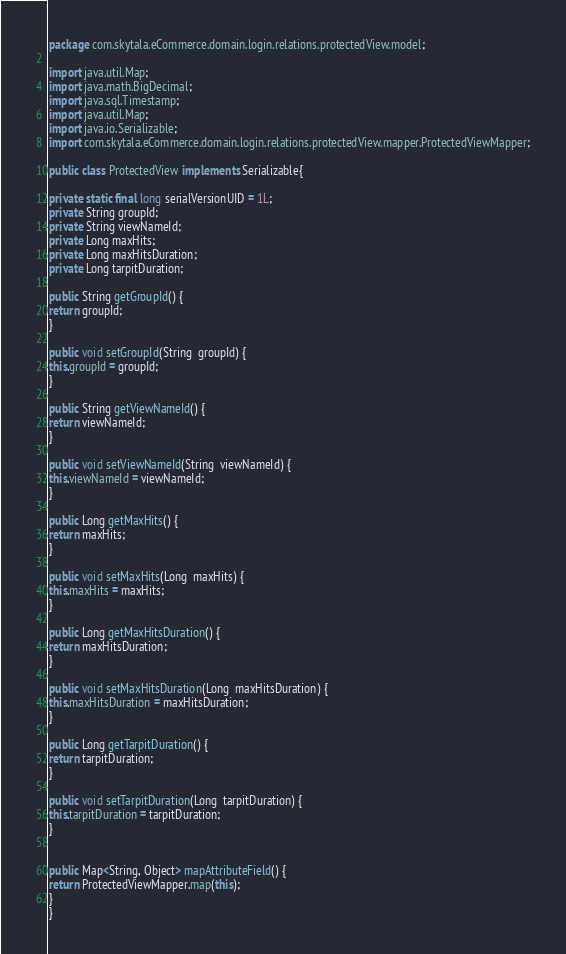Convert code to text. <code><loc_0><loc_0><loc_500><loc_500><_Java_>package com.skytala.eCommerce.domain.login.relations.protectedView.model;

import java.util.Map;
import java.math.BigDecimal;
import java.sql.Timestamp;
import java.util.Map;
import java.io.Serializable;
import com.skytala.eCommerce.domain.login.relations.protectedView.mapper.ProtectedViewMapper;

public class ProtectedView implements Serializable{

private static final long serialVersionUID = 1L;
private String groupId;
private String viewNameId;
private Long maxHits;
private Long maxHitsDuration;
private Long tarpitDuration;

public String getGroupId() {
return groupId;
}

public void setGroupId(String  groupId) {
this.groupId = groupId;
}

public String getViewNameId() {
return viewNameId;
}

public void setViewNameId(String  viewNameId) {
this.viewNameId = viewNameId;
}

public Long getMaxHits() {
return maxHits;
}

public void setMaxHits(Long  maxHits) {
this.maxHits = maxHits;
}

public Long getMaxHitsDuration() {
return maxHitsDuration;
}

public void setMaxHitsDuration(Long  maxHitsDuration) {
this.maxHitsDuration = maxHitsDuration;
}

public Long getTarpitDuration() {
return tarpitDuration;
}

public void setTarpitDuration(Long  tarpitDuration) {
this.tarpitDuration = tarpitDuration;
}


public Map<String, Object> mapAttributeField() {
return ProtectedViewMapper.map(this);
}
}
</code> 